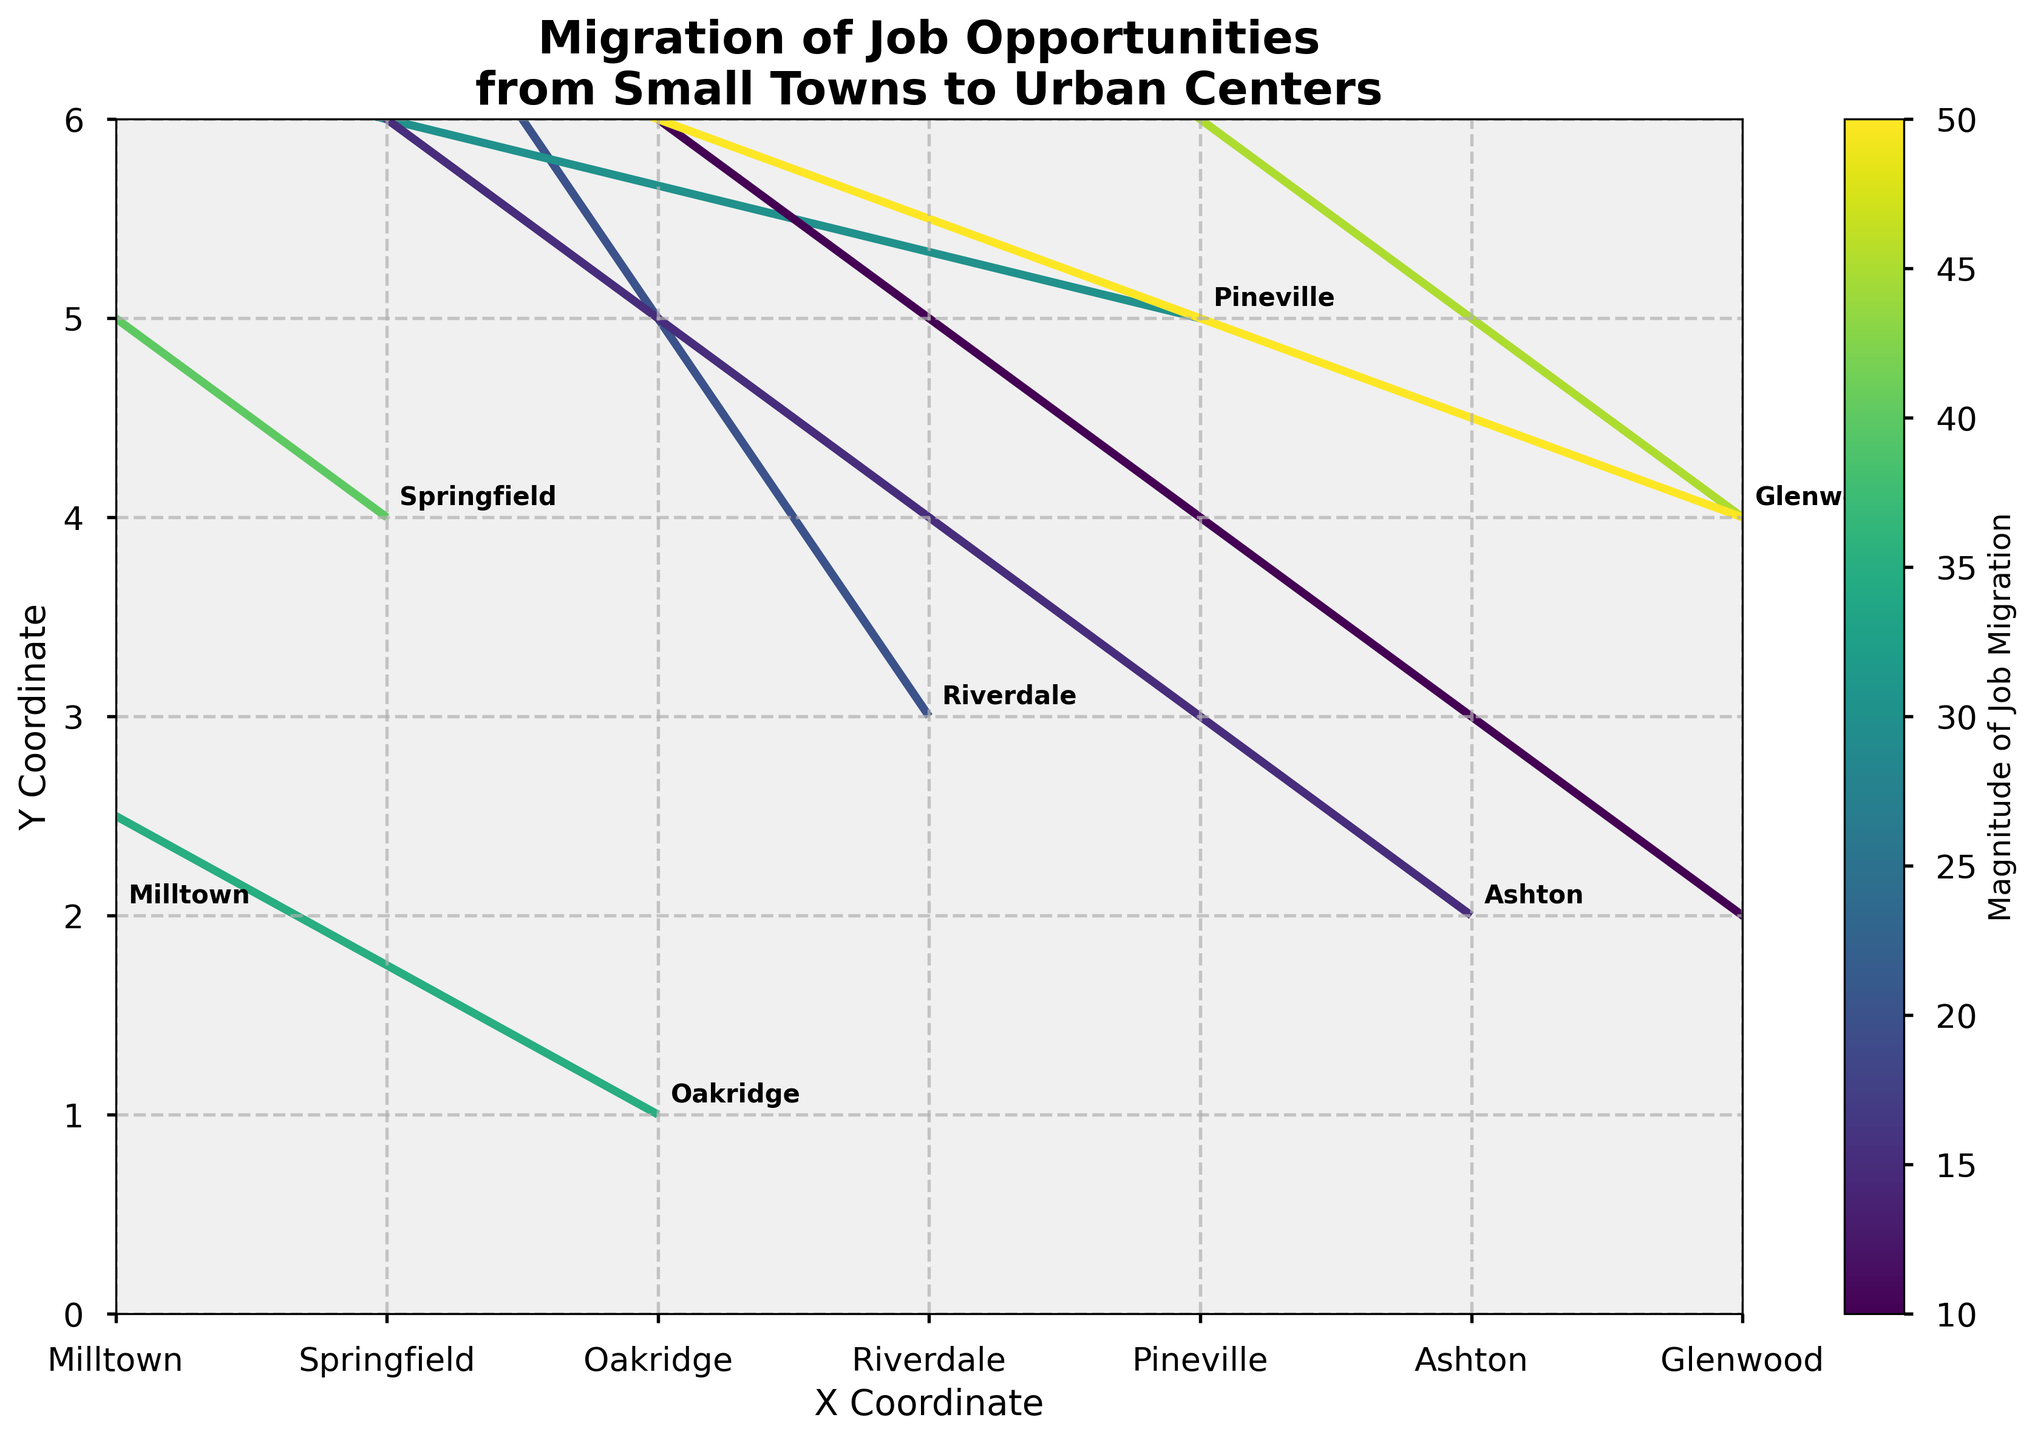What is the title of the plot? The title of the plot is usually found at the top of the figure. In this case, the title clearly states the main topic.
Answer: Migration of Job Opportunities from Small Towns to Urban Centers How many data points are plotted? Count the number of quivers (arrows) in the plot. Each one represents a data point.
Answer: 10 Which town shows the largest migration in job opportunities? Look for the longest arrow, as it represents the largest magnitude of job migration. The color bar helps indicate the magnitude if arrows are similar in length.
Answer: Fairview In which direction does the job migration generally move in Milltown? Check the direction of the arrow originating from Milltown. It provides the visual cue for the direction of migration from this town.
Answer: Southeast What is the magnitude of job migration for Lakeside? Use the color bar to associate the color of Lakeside's arrow with the magnitude scale.
Answer: 10 Which town shows the smallest migration in job opportunities? Identify the shortest arrow or the color representing the lowest magnitude in the plot.
Answer: Lakeside Are there more towns with westward job migration or eastward job migration? Compare the number of arrows pointing towards the left (westward) to those pointing towards the right (eastward). Count each to determine the answer.
Answer: Westward Which two towns have the same U and V values? Compare the U and V values for each town and identify which pairs match exactly.
Answer: Riverdale and Springfield What is the average magnitude of job migration across all towns? Sum all the magnitudes and divide by the number of data points (towns). This will give the average magnitude.
Answer: (25 + 40 + 35 + 20 + 30 + 15 + 45 + 10 + 50 + 35) / 10 = 30.5 In which range do most of the Y coordinates fall? Review the Y coordinates of all the towns and identify the range where most of them fall.
Answer: 1-4 